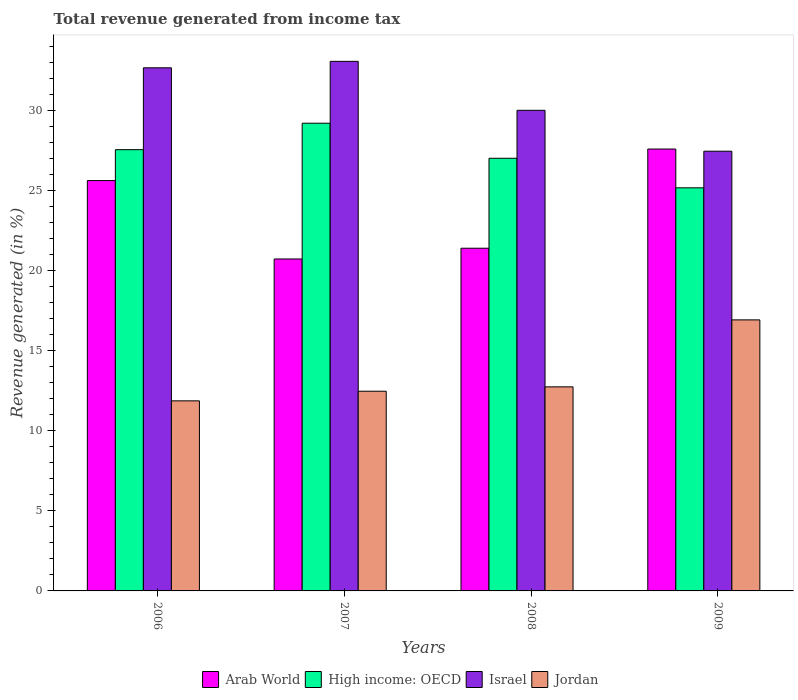How many different coloured bars are there?
Keep it short and to the point. 4. What is the label of the 3rd group of bars from the left?
Provide a succinct answer. 2008. In how many cases, is the number of bars for a given year not equal to the number of legend labels?
Provide a succinct answer. 0. What is the total revenue generated in Arab World in 2006?
Your answer should be very brief. 25.61. Across all years, what is the maximum total revenue generated in High income: OECD?
Your answer should be compact. 29.19. Across all years, what is the minimum total revenue generated in Israel?
Keep it short and to the point. 27.44. What is the total total revenue generated in Israel in the graph?
Provide a succinct answer. 123.12. What is the difference between the total revenue generated in Arab World in 2006 and that in 2007?
Your answer should be very brief. 4.89. What is the difference between the total revenue generated in Jordan in 2007 and the total revenue generated in High income: OECD in 2009?
Offer a terse response. -12.69. What is the average total revenue generated in Jordan per year?
Ensure brevity in your answer.  13.49. In the year 2008, what is the difference between the total revenue generated in Jordan and total revenue generated in Arab World?
Your response must be concise. -8.65. What is the ratio of the total revenue generated in Arab World in 2008 to that in 2009?
Your answer should be compact. 0.78. Is the difference between the total revenue generated in Jordan in 2006 and 2008 greater than the difference between the total revenue generated in Arab World in 2006 and 2008?
Give a very brief answer. No. What is the difference between the highest and the second highest total revenue generated in Israel?
Your response must be concise. 0.4. What is the difference between the highest and the lowest total revenue generated in Arab World?
Offer a terse response. 6.86. Is the sum of the total revenue generated in Jordan in 2006 and 2007 greater than the maximum total revenue generated in Arab World across all years?
Provide a succinct answer. No. Is it the case that in every year, the sum of the total revenue generated in Arab World and total revenue generated in High income: OECD is greater than the sum of total revenue generated in Israel and total revenue generated in Jordan?
Offer a terse response. Yes. What does the 3rd bar from the left in 2007 represents?
Give a very brief answer. Israel. What does the 2nd bar from the right in 2008 represents?
Keep it short and to the point. Israel. Is it the case that in every year, the sum of the total revenue generated in Israel and total revenue generated in Arab World is greater than the total revenue generated in High income: OECD?
Provide a succinct answer. Yes. How many bars are there?
Your answer should be compact. 16. Are all the bars in the graph horizontal?
Ensure brevity in your answer.  No. Does the graph contain any zero values?
Your answer should be compact. No. How many legend labels are there?
Keep it short and to the point. 4. How are the legend labels stacked?
Give a very brief answer. Horizontal. What is the title of the graph?
Offer a very short reply. Total revenue generated from income tax. Does "High income" appear as one of the legend labels in the graph?
Provide a short and direct response. No. What is the label or title of the Y-axis?
Ensure brevity in your answer.  Revenue generated (in %). What is the Revenue generated (in %) in Arab World in 2006?
Make the answer very short. 25.61. What is the Revenue generated (in %) in High income: OECD in 2006?
Provide a short and direct response. 27.53. What is the Revenue generated (in %) in Israel in 2006?
Ensure brevity in your answer.  32.64. What is the Revenue generated (in %) of Jordan in 2006?
Ensure brevity in your answer.  11.86. What is the Revenue generated (in %) in Arab World in 2007?
Offer a terse response. 20.71. What is the Revenue generated (in %) of High income: OECD in 2007?
Give a very brief answer. 29.19. What is the Revenue generated (in %) in Israel in 2007?
Provide a short and direct response. 33.05. What is the Revenue generated (in %) in Jordan in 2007?
Your answer should be very brief. 12.46. What is the Revenue generated (in %) of Arab World in 2008?
Your answer should be compact. 21.38. What is the Revenue generated (in %) in High income: OECD in 2008?
Give a very brief answer. 27. What is the Revenue generated (in %) of Israel in 2008?
Provide a succinct answer. 29.99. What is the Revenue generated (in %) of Jordan in 2008?
Ensure brevity in your answer.  12.73. What is the Revenue generated (in %) in Arab World in 2009?
Provide a succinct answer. 27.57. What is the Revenue generated (in %) of High income: OECD in 2009?
Offer a terse response. 25.15. What is the Revenue generated (in %) of Israel in 2009?
Your answer should be very brief. 27.44. What is the Revenue generated (in %) of Jordan in 2009?
Your answer should be very brief. 16.91. Across all years, what is the maximum Revenue generated (in %) in Arab World?
Your answer should be compact. 27.57. Across all years, what is the maximum Revenue generated (in %) of High income: OECD?
Provide a succinct answer. 29.19. Across all years, what is the maximum Revenue generated (in %) in Israel?
Keep it short and to the point. 33.05. Across all years, what is the maximum Revenue generated (in %) in Jordan?
Give a very brief answer. 16.91. Across all years, what is the minimum Revenue generated (in %) in Arab World?
Keep it short and to the point. 20.71. Across all years, what is the minimum Revenue generated (in %) of High income: OECD?
Your answer should be compact. 25.15. Across all years, what is the minimum Revenue generated (in %) in Israel?
Your answer should be compact. 27.44. Across all years, what is the minimum Revenue generated (in %) in Jordan?
Your answer should be compact. 11.86. What is the total Revenue generated (in %) of Arab World in the graph?
Your answer should be compact. 95.28. What is the total Revenue generated (in %) of High income: OECD in the graph?
Keep it short and to the point. 108.87. What is the total Revenue generated (in %) in Israel in the graph?
Your answer should be very brief. 123.12. What is the total Revenue generated (in %) in Jordan in the graph?
Ensure brevity in your answer.  53.97. What is the difference between the Revenue generated (in %) in Arab World in 2006 and that in 2007?
Ensure brevity in your answer.  4.89. What is the difference between the Revenue generated (in %) of High income: OECD in 2006 and that in 2007?
Offer a terse response. -1.65. What is the difference between the Revenue generated (in %) of Israel in 2006 and that in 2007?
Give a very brief answer. -0.4. What is the difference between the Revenue generated (in %) in Jordan in 2006 and that in 2007?
Offer a very short reply. -0.6. What is the difference between the Revenue generated (in %) in Arab World in 2006 and that in 2008?
Keep it short and to the point. 4.22. What is the difference between the Revenue generated (in %) in High income: OECD in 2006 and that in 2008?
Keep it short and to the point. 0.54. What is the difference between the Revenue generated (in %) of Israel in 2006 and that in 2008?
Offer a terse response. 2.65. What is the difference between the Revenue generated (in %) of Jordan in 2006 and that in 2008?
Provide a succinct answer. -0.87. What is the difference between the Revenue generated (in %) in Arab World in 2006 and that in 2009?
Your response must be concise. -1.97. What is the difference between the Revenue generated (in %) of High income: OECD in 2006 and that in 2009?
Your answer should be compact. 2.38. What is the difference between the Revenue generated (in %) in Israel in 2006 and that in 2009?
Your response must be concise. 5.2. What is the difference between the Revenue generated (in %) of Jordan in 2006 and that in 2009?
Provide a short and direct response. -5.05. What is the difference between the Revenue generated (in %) in Arab World in 2007 and that in 2008?
Offer a very short reply. -0.67. What is the difference between the Revenue generated (in %) in High income: OECD in 2007 and that in 2008?
Your response must be concise. 2.19. What is the difference between the Revenue generated (in %) of Israel in 2007 and that in 2008?
Ensure brevity in your answer.  3.05. What is the difference between the Revenue generated (in %) of Jordan in 2007 and that in 2008?
Your response must be concise. -0.27. What is the difference between the Revenue generated (in %) in Arab World in 2007 and that in 2009?
Provide a succinct answer. -6.86. What is the difference between the Revenue generated (in %) in High income: OECD in 2007 and that in 2009?
Keep it short and to the point. 4.03. What is the difference between the Revenue generated (in %) of Israel in 2007 and that in 2009?
Keep it short and to the point. 5.61. What is the difference between the Revenue generated (in %) of Jordan in 2007 and that in 2009?
Your response must be concise. -4.45. What is the difference between the Revenue generated (in %) in Arab World in 2008 and that in 2009?
Offer a terse response. -6.19. What is the difference between the Revenue generated (in %) in High income: OECD in 2008 and that in 2009?
Your answer should be compact. 1.84. What is the difference between the Revenue generated (in %) of Israel in 2008 and that in 2009?
Your answer should be very brief. 2.55. What is the difference between the Revenue generated (in %) in Jordan in 2008 and that in 2009?
Ensure brevity in your answer.  -4.18. What is the difference between the Revenue generated (in %) in Arab World in 2006 and the Revenue generated (in %) in High income: OECD in 2007?
Your response must be concise. -3.58. What is the difference between the Revenue generated (in %) of Arab World in 2006 and the Revenue generated (in %) of Israel in 2007?
Your response must be concise. -7.44. What is the difference between the Revenue generated (in %) of Arab World in 2006 and the Revenue generated (in %) of Jordan in 2007?
Keep it short and to the point. 13.14. What is the difference between the Revenue generated (in %) of High income: OECD in 2006 and the Revenue generated (in %) of Israel in 2007?
Your response must be concise. -5.51. What is the difference between the Revenue generated (in %) of High income: OECD in 2006 and the Revenue generated (in %) of Jordan in 2007?
Ensure brevity in your answer.  15.07. What is the difference between the Revenue generated (in %) in Israel in 2006 and the Revenue generated (in %) in Jordan in 2007?
Your answer should be compact. 20.18. What is the difference between the Revenue generated (in %) of Arab World in 2006 and the Revenue generated (in %) of High income: OECD in 2008?
Offer a very short reply. -1.39. What is the difference between the Revenue generated (in %) in Arab World in 2006 and the Revenue generated (in %) in Israel in 2008?
Your answer should be compact. -4.39. What is the difference between the Revenue generated (in %) of Arab World in 2006 and the Revenue generated (in %) of Jordan in 2008?
Keep it short and to the point. 12.87. What is the difference between the Revenue generated (in %) in High income: OECD in 2006 and the Revenue generated (in %) in Israel in 2008?
Provide a short and direct response. -2.46. What is the difference between the Revenue generated (in %) in High income: OECD in 2006 and the Revenue generated (in %) in Jordan in 2008?
Ensure brevity in your answer.  14.8. What is the difference between the Revenue generated (in %) in Israel in 2006 and the Revenue generated (in %) in Jordan in 2008?
Your answer should be compact. 19.91. What is the difference between the Revenue generated (in %) in Arab World in 2006 and the Revenue generated (in %) in High income: OECD in 2009?
Your answer should be very brief. 0.45. What is the difference between the Revenue generated (in %) in Arab World in 2006 and the Revenue generated (in %) in Israel in 2009?
Your answer should be compact. -1.83. What is the difference between the Revenue generated (in %) in Arab World in 2006 and the Revenue generated (in %) in Jordan in 2009?
Keep it short and to the point. 8.69. What is the difference between the Revenue generated (in %) of High income: OECD in 2006 and the Revenue generated (in %) of Israel in 2009?
Ensure brevity in your answer.  0.1. What is the difference between the Revenue generated (in %) of High income: OECD in 2006 and the Revenue generated (in %) of Jordan in 2009?
Keep it short and to the point. 10.62. What is the difference between the Revenue generated (in %) in Israel in 2006 and the Revenue generated (in %) in Jordan in 2009?
Your answer should be compact. 15.73. What is the difference between the Revenue generated (in %) in Arab World in 2007 and the Revenue generated (in %) in High income: OECD in 2008?
Provide a succinct answer. -6.28. What is the difference between the Revenue generated (in %) of Arab World in 2007 and the Revenue generated (in %) of Israel in 2008?
Give a very brief answer. -9.28. What is the difference between the Revenue generated (in %) in Arab World in 2007 and the Revenue generated (in %) in Jordan in 2008?
Ensure brevity in your answer.  7.98. What is the difference between the Revenue generated (in %) of High income: OECD in 2007 and the Revenue generated (in %) of Israel in 2008?
Ensure brevity in your answer.  -0.81. What is the difference between the Revenue generated (in %) in High income: OECD in 2007 and the Revenue generated (in %) in Jordan in 2008?
Provide a short and direct response. 16.45. What is the difference between the Revenue generated (in %) in Israel in 2007 and the Revenue generated (in %) in Jordan in 2008?
Ensure brevity in your answer.  20.31. What is the difference between the Revenue generated (in %) of Arab World in 2007 and the Revenue generated (in %) of High income: OECD in 2009?
Your answer should be very brief. -4.44. What is the difference between the Revenue generated (in %) in Arab World in 2007 and the Revenue generated (in %) in Israel in 2009?
Provide a succinct answer. -6.73. What is the difference between the Revenue generated (in %) in Arab World in 2007 and the Revenue generated (in %) in Jordan in 2009?
Keep it short and to the point. 3.8. What is the difference between the Revenue generated (in %) of High income: OECD in 2007 and the Revenue generated (in %) of Israel in 2009?
Provide a succinct answer. 1.75. What is the difference between the Revenue generated (in %) in High income: OECD in 2007 and the Revenue generated (in %) in Jordan in 2009?
Your answer should be compact. 12.27. What is the difference between the Revenue generated (in %) in Israel in 2007 and the Revenue generated (in %) in Jordan in 2009?
Your answer should be compact. 16.13. What is the difference between the Revenue generated (in %) in Arab World in 2008 and the Revenue generated (in %) in High income: OECD in 2009?
Make the answer very short. -3.77. What is the difference between the Revenue generated (in %) of Arab World in 2008 and the Revenue generated (in %) of Israel in 2009?
Make the answer very short. -6.05. What is the difference between the Revenue generated (in %) of Arab World in 2008 and the Revenue generated (in %) of Jordan in 2009?
Keep it short and to the point. 4.47. What is the difference between the Revenue generated (in %) of High income: OECD in 2008 and the Revenue generated (in %) of Israel in 2009?
Your answer should be very brief. -0.44. What is the difference between the Revenue generated (in %) in High income: OECD in 2008 and the Revenue generated (in %) in Jordan in 2009?
Ensure brevity in your answer.  10.08. What is the difference between the Revenue generated (in %) in Israel in 2008 and the Revenue generated (in %) in Jordan in 2009?
Your response must be concise. 13.08. What is the average Revenue generated (in %) of Arab World per year?
Provide a short and direct response. 23.82. What is the average Revenue generated (in %) in High income: OECD per year?
Provide a succinct answer. 27.22. What is the average Revenue generated (in %) of Israel per year?
Keep it short and to the point. 30.78. What is the average Revenue generated (in %) of Jordan per year?
Offer a terse response. 13.49. In the year 2006, what is the difference between the Revenue generated (in %) of Arab World and Revenue generated (in %) of High income: OECD?
Offer a terse response. -1.93. In the year 2006, what is the difference between the Revenue generated (in %) of Arab World and Revenue generated (in %) of Israel?
Your answer should be compact. -7.04. In the year 2006, what is the difference between the Revenue generated (in %) of Arab World and Revenue generated (in %) of Jordan?
Give a very brief answer. 13.75. In the year 2006, what is the difference between the Revenue generated (in %) in High income: OECD and Revenue generated (in %) in Israel?
Keep it short and to the point. -5.11. In the year 2006, what is the difference between the Revenue generated (in %) of High income: OECD and Revenue generated (in %) of Jordan?
Provide a short and direct response. 15.67. In the year 2006, what is the difference between the Revenue generated (in %) of Israel and Revenue generated (in %) of Jordan?
Provide a short and direct response. 20.78. In the year 2007, what is the difference between the Revenue generated (in %) in Arab World and Revenue generated (in %) in High income: OECD?
Keep it short and to the point. -8.47. In the year 2007, what is the difference between the Revenue generated (in %) in Arab World and Revenue generated (in %) in Israel?
Offer a terse response. -12.33. In the year 2007, what is the difference between the Revenue generated (in %) in Arab World and Revenue generated (in %) in Jordan?
Keep it short and to the point. 8.25. In the year 2007, what is the difference between the Revenue generated (in %) of High income: OECD and Revenue generated (in %) of Israel?
Ensure brevity in your answer.  -3.86. In the year 2007, what is the difference between the Revenue generated (in %) in High income: OECD and Revenue generated (in %) in Jordan?
Your response must be concise. 16.72. In the year 2007, what is the difference between the Revenue generated (in %) of Israel and Revenue generated (in %) of Jordan?
Make the answer very short. 20.59. In the year 2008, what is the difference between the Revenue generated (in %) in Arab World and Revenue generated (in %) in High income: OECD?
Offer a very short reply. -5.61. In the year 2008, what is the difference between the Revenue generated (in %) of Arab World and Revenue generated (in %) of Israel?
Make the answer very short. -8.61. In the year 2008, what is the difference between the Revenue generated (in %) in Arab World and Revenue generated (in %) in Jordan?
Ensure brevity in your answer.  8.65. In the year 2008, what is the difference between the Revenue generated (in %) of High income: OECD and Revenue generated (in %) of Israel?
Ensure brevity in your answer.  -2.99. In the year 2008, what is the difference between the Revenue generated (in %) in High income: OECD and Revenue generated (in %) in Jordan?
Give a very brief answer. 14.26. In the year 2008, what is the difference between the Revenue generated (in %) of Israel and Revenue generated (in %) of Jordan?
Your response must be concise. 17.26. In the year 2009, what is the difference between the Revenue generated (in %) of Arab World and Revenue generated (in %) of High income: OECD?
Your answer should be very brief. 2.42. In the year 2009, what is the difference between the Revenue generated (in %) in Arab World and Revenue generated (in %) in Israel?
Provide a succinct answer. 0.13. In the year 2009, what is the difference between the Revenue generated (in %) in Arab World and Revenue generated (in %) in Jordan?
Keep it short and to the point. 10.66. In the year 2009, what is the difference between the Revenue generated (in %) of High income: OECD and Revenue generated (in %) of Israel?
Your response must be concise. -2.29. In the year 2009, what is the difference between the Revenue generated (in %) of High income: OECD and Revenue generated (in %) of Jordan?
Offer a terse response. 8.24. In the year 2009, what is the difference between the Revenue generated (in %) in Israel and Revenue generated (in %) in Jordan?
Offer a terse response. 10.53. What is the ratio of the Revenue generated (in %) in Arab World in 2006 to that in 2007?
Give a very brief answer. 1.24. What is the ratio of the Revenue generated (in %) of High income: OECD in 2006 to that in 2007?
Provide a succinct answer. 0.94. What is the ratio of the Revenue generated (in %) in Jordan in 2006 to that in 2007?
Provide a short and direct response. 0.95. What is the ratio of the Revenue generated (in %) of Arab World in 2006 to that in 2008?
Provide a short and direct response. 1.2. What is the ratio of the Revenue generated (in %) of High income: OECD in 2006 to that in 2008?
Offer a very short reply. 1.02. What is the ratio of the Revenue generated (in %) in Israel in 2006 to that in 2008?
Provide a succinct answer. 1.09. What is the ratio of the Revenue generated (in %) of Jordan in 2006 to that in 2008?
Offer a very short reply. 0.93. What is the ratio of the Revenue generated (in %) in High income: OECD in 2006 to that in 2009?
Your response must be concise. 1.09. What is the ratio of the Revenue generated (in %) in Israel in 2006 to that in 2009?
Your answer should be very brief. 1.19. What is the ratio of the Revenue generated (in %) of Jordan in 2006 to that in 2009?
Your answer should be very brief. 0.7. What is the ratio of the Revenue generated (in %) in Arab World in 2007 to that in 2008?
Your answer should be very brief. 0.97. What is the ratio of the Revenue generated (in %) of High income: OECD in 2007 to that in 2008?
Your response must be concise. 1.08. What is the ratio of the Revenue generated (in %) in Israel in 2007 to that in 2008?
Offer a very short reply. 1.1. What is the ratio of the Revenue generated (in %) of Jordan in 2007 to that in 2008?
Your answer should be compact. 0.98. What is the ratio of the Revenue generated (in %) in Arab World in 2007 to that in 2009?
Provide a succinct answer. 0.75. What is the ratio of the Revenue generated (in %) in High income: OECD in 2007 to that in 2009?
Your response must be concise. 1.16. What is the ratio of the Revenue generated (in %) of Israel in 2007 to that in 2009?
Provide a succinct answer. 1.2. What is the ratio of the Revenue generated (in %) in Jordan in 2007 to that in 2009?
Ensure brevity in your answer.  0.74. What is the ratio of the Revenue generated (in %) of Arab World in 2008 to that in 2009?
Offer a very short reply. 0.78. What is the ratio of the Revenue generated (in %) in High income: OECD in 2008 to that in 2009?
Ensure brevity in your answer.  1.07. What is the ratio of the Revenue generated (in %) in Israel in 2008 to that in 2009?
Your response must be concise. 1.09. What is the ratio of the Revenue generated (in %) of Jordan in 2008 to that in 2009?
Your answer should be very brief. 0.75. What is the difference between the highest and the second highest Revenue generated (in %) of Arab World?
Offer a very short reply. 1.97. What is the difference between the highest and the second highest Revenue generated (in %) of High income: OECD?
Your response must be concise. 1.65. What is the difference between the highest and the second highest Revenue generated (in %) in Israel?
Ensure brevity in your answer.  0.4. What is the difference between the highest and the second highest Revenue generated (in %) of Jordan?
Your response must be concise. 4.18. What is the difference between the highest and the lowest Revenue generated (in %) of Arab World?
Provide a succinct answer. 6.86. What is the difference between the highest and the lowest Revenue generated (in %) of High income: OECD?
Provide a short and direct response. 4.03. What is the difference between the highest and the lowest Revenue generated (in %) in Israel?
Your response must be concise. 5.61. What is the difference between the highest and the lowest Revenue generated (in %) of Jordan?
Provide a short and direct response. 5.05. 